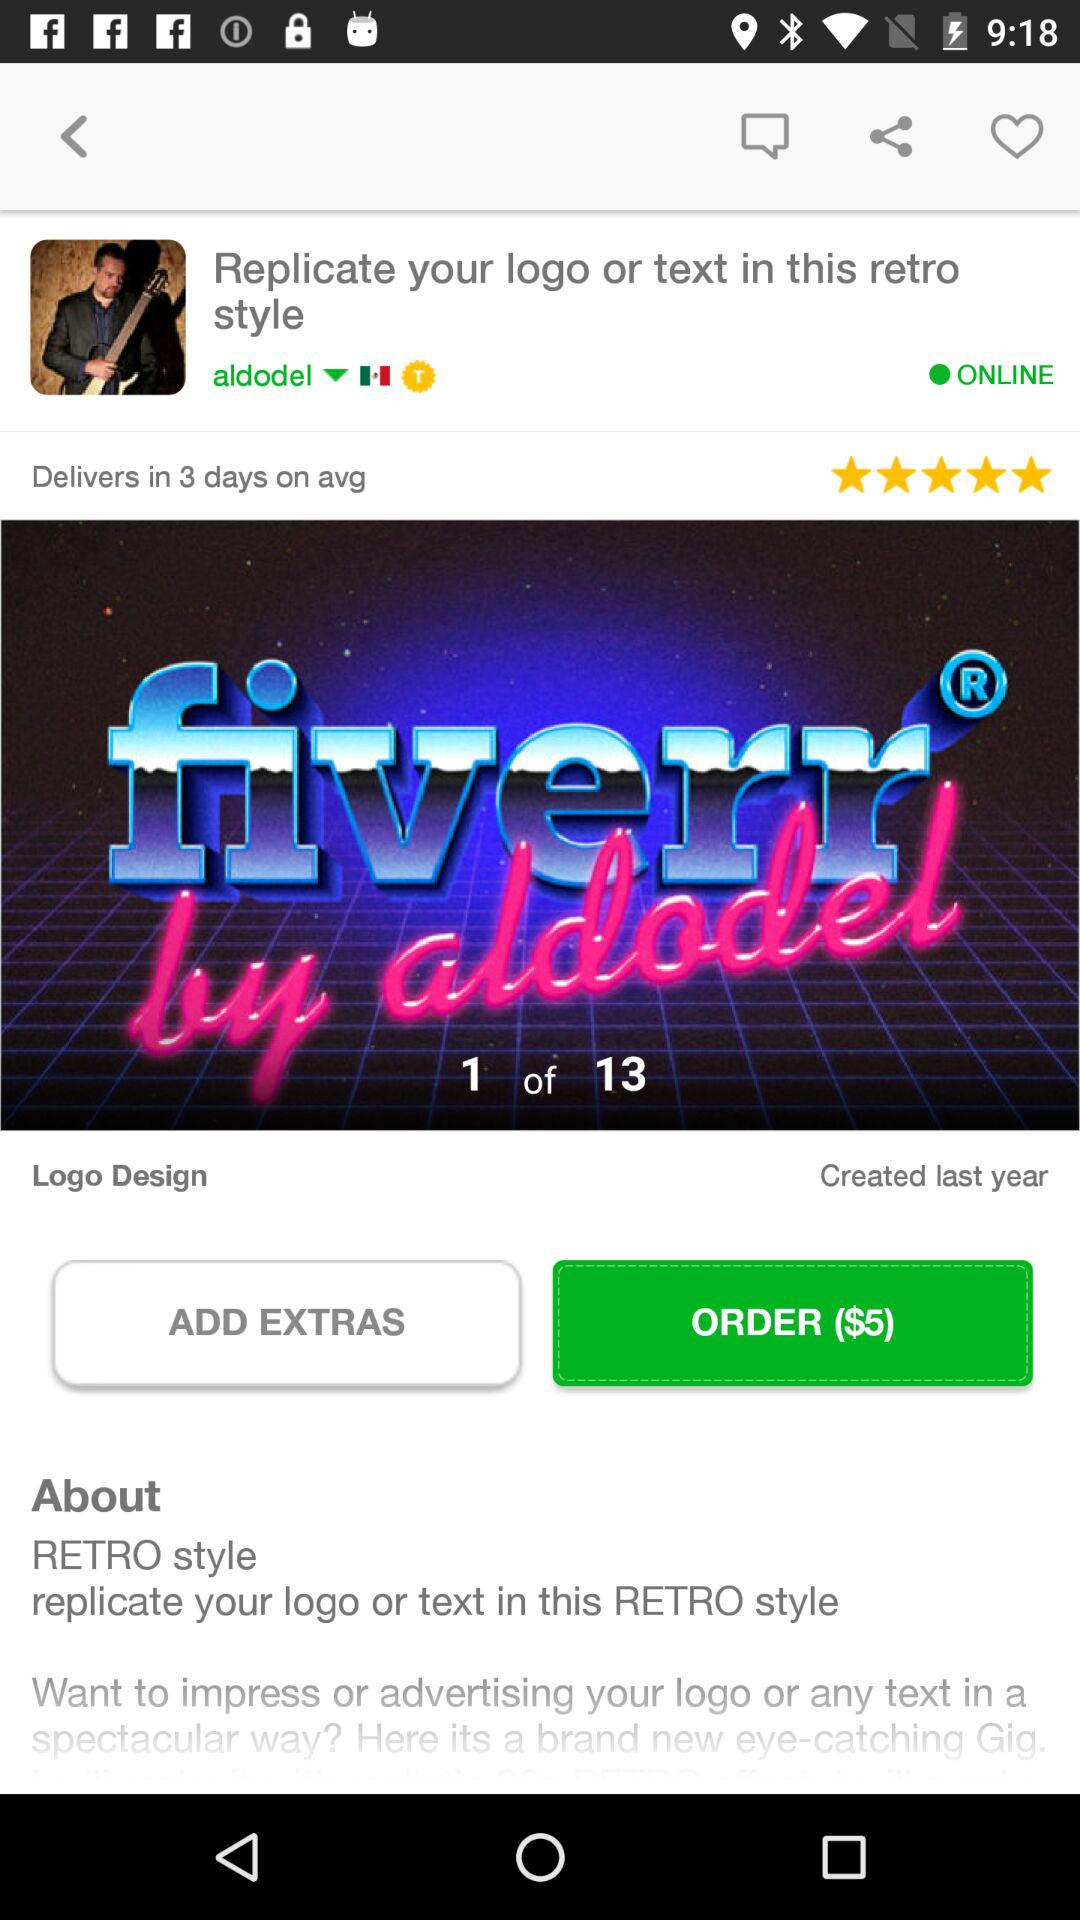When was the logo design created? The logo design was created last year. 